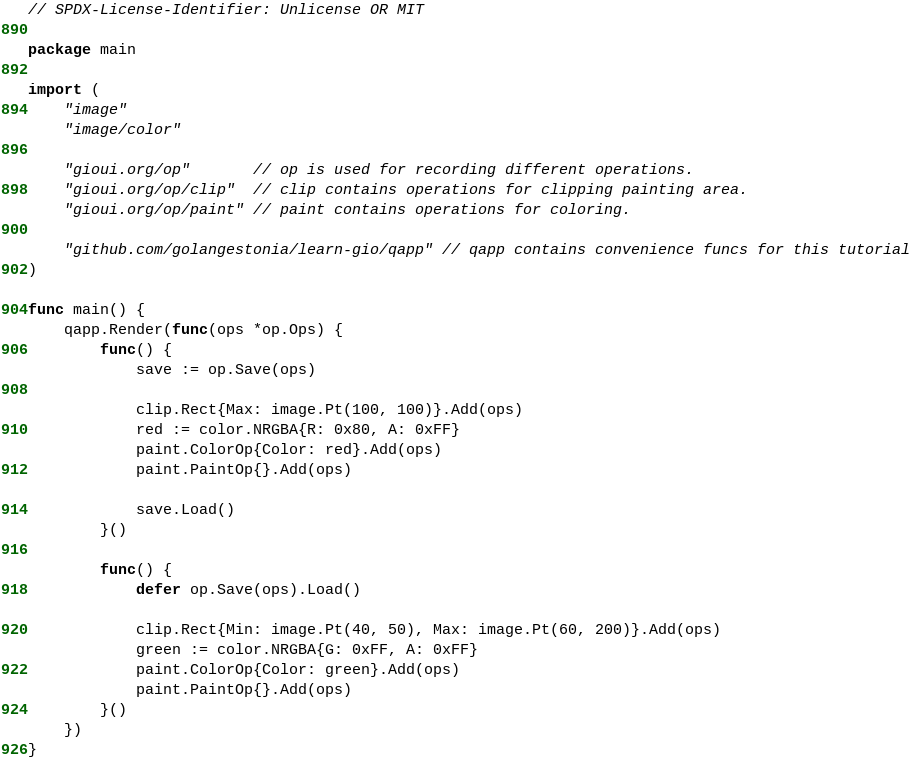<code> <loc_0><loc_0><loc_500><loc_500><_Go_>// SPDX-License-Identifier: Unlicense OR MIT

package main

import (
	"image"
	"image/color"

	"gioui.org/op"       // op is used for recording different operations.
	"gioui.org/op/clip"  // clip contains operations for clipping painting area.
	"gioui.org/op/paint" // paint contains operations for coloring.

	"github.com/golangestonia/learn-gio/qapp" // qapp contains convenience funcs for this tutorial
)

func main() {
	qapp.Render(func(ops *op.Ops) {
		func() {
			save := op.Save(ops)

			clip.Rect{Max: image.Pt(100, 100)}.Add(ops)
			red := color.NRGBA{R: 0x80, A: 0xFF}
			paint.ColorOp{Color: red}.Add(ops)
			paint.PaintOp{}.Add(ops)

			save.Load()
		}()

		func() {
			defer op.Save(ops).Load()

			clip.Rect{Min: image.Pt(40, 50), Max: image.Pt(60, 200)}.Add(ops)
			green := color.NRGBA{G: 0xFF, A: 0xFF}
			paint.ColorOp{Color: green}.Add(ops)
			paint.PaintOp{}.Add(ops)
		}()
	})
}
</code> 